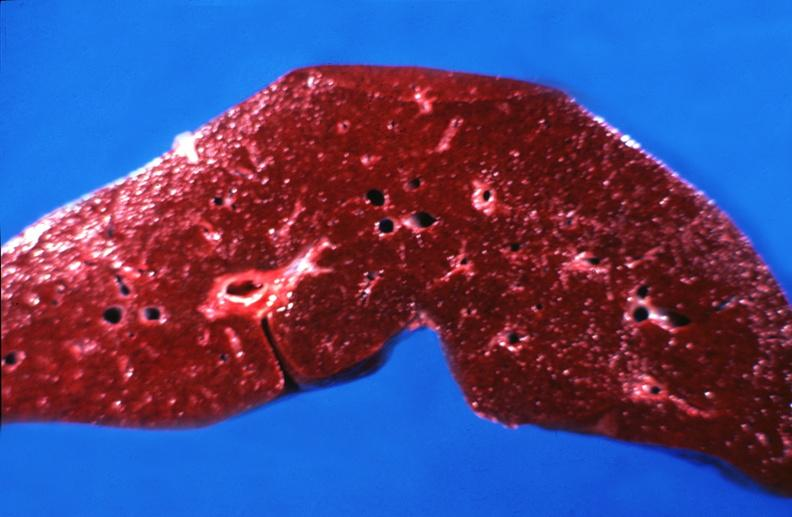s liver present?
Answer the question using a single word or phrase. Yes 